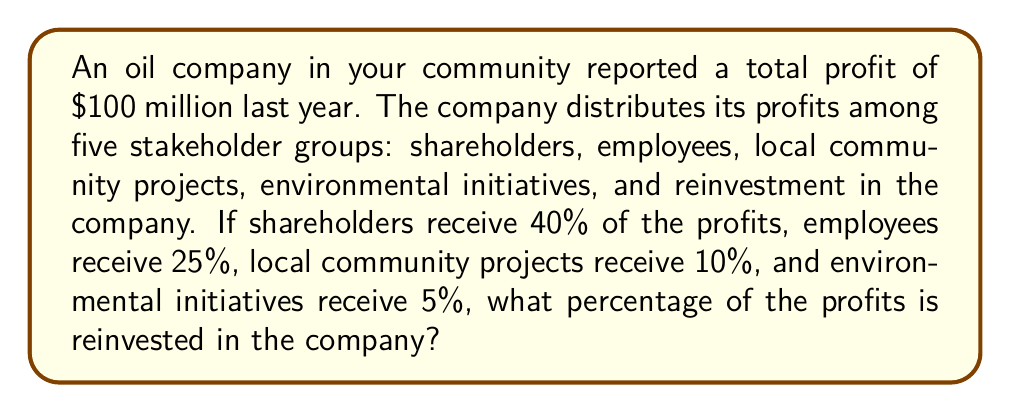Give your solution to this math problem. Let's approach this step-by-step:

1. First, let's identify the known percentages:
   - Shareholders: 40%
   - Employees: 25%
   - Local community projects: 10%
   - Environmental initiatives: 5%

2. To find the percentage reinvested in the company, we need to subtract the sum of the known percentages from 100%:

   $$ \text{Reinvestment} = 100\% - (\text{Shareholders} + \text{Employees} + \text{Community} + \text{Environment}) $$

3. Let's substitute the known values:

   $$ \text{Reinvestment} = 100\% - (40\% + 25\% + 10\% + 5\%) $$

4. Now, let's perform the addition inside the parentheses:

   $$ \text{Reinvestment} = 100\% - 80\% $$

5. Finally, we can subtract:

   $$ \text{Reinvestment} = 20\% $$

Therefore, 20% of the profits are reinvested in the company.
Answer: 20% 